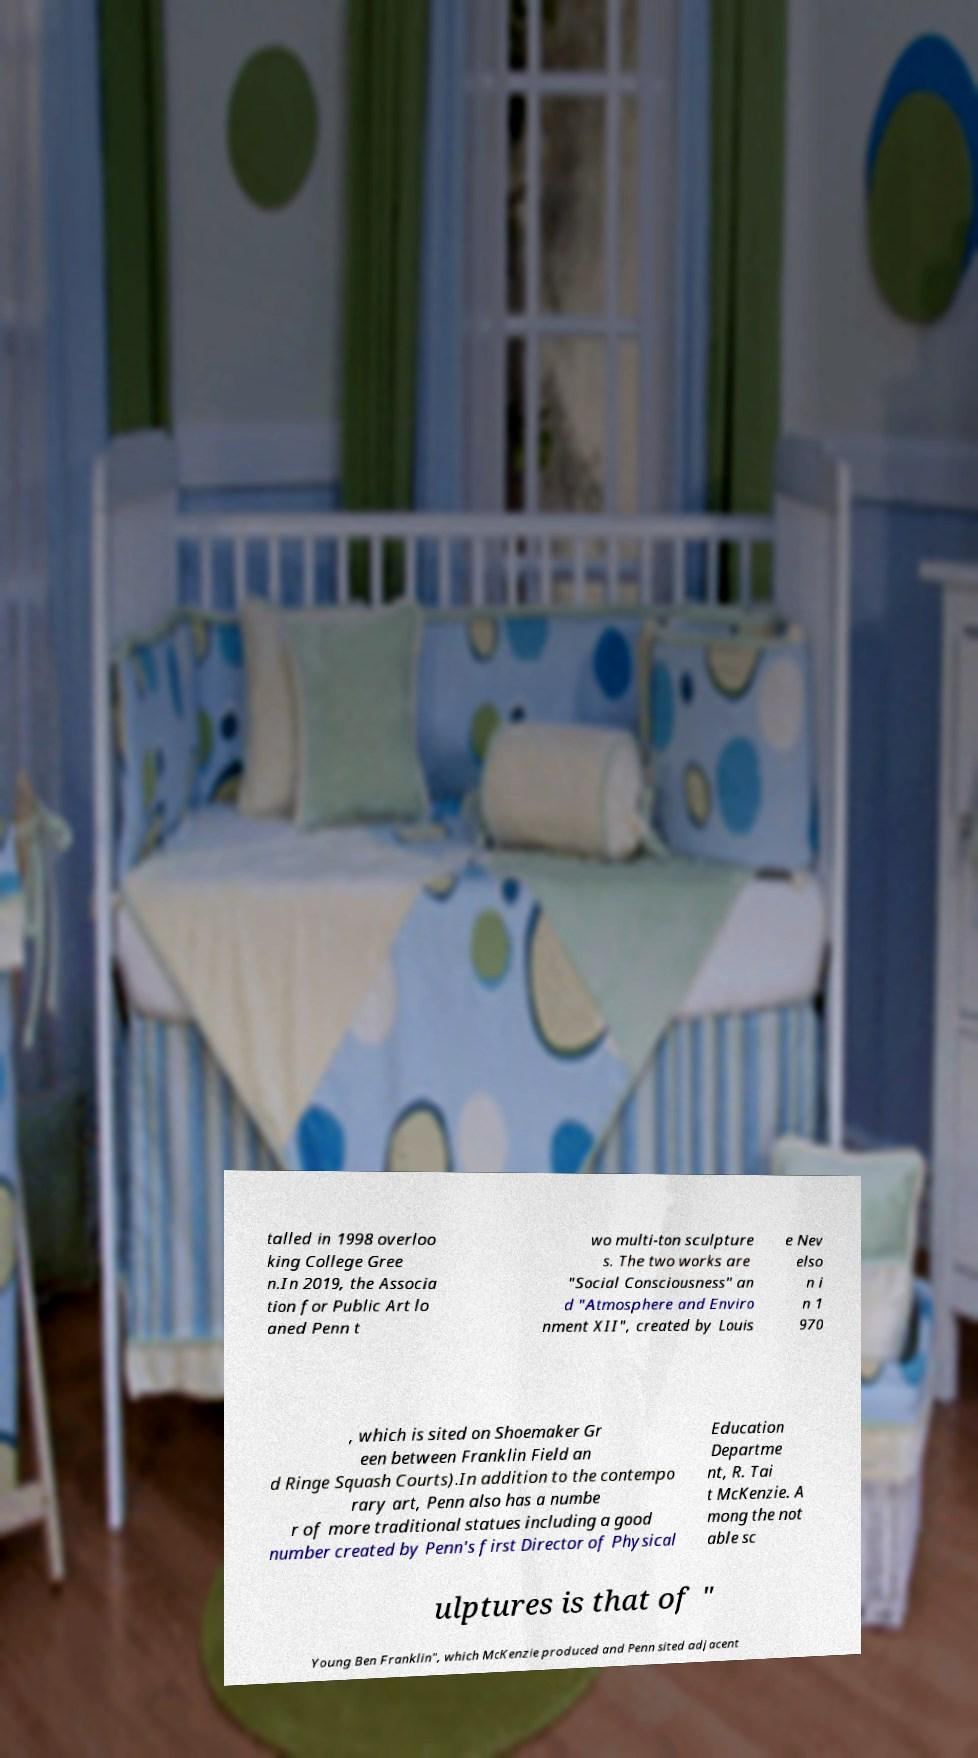I need the written content from this picture converted into text. Can you do that? talled in 1998 overloo king College Gree n.In 2019, the Associa tion for Public Art lo aned Penn t wo multi-ton sculpture s. The two works are "Social Consciousness" an d "Atmosphere and Enviro nment XII", created by Louis e Nev elso n i n 1 970 , which is sited on Shoemaker Gr een between Franklin Field an d Ringe Squash Courts).In addition to the contempo rary art, Penn also has a numbe r of more traditional statues including a good number created by Penn's first Director of Physical Education Departme nt, R. Tai t McKenzie. A mong the not able sc ulptures is that of " Young Ben Franklin", which McKenzie produced and Penn sited adjacent 